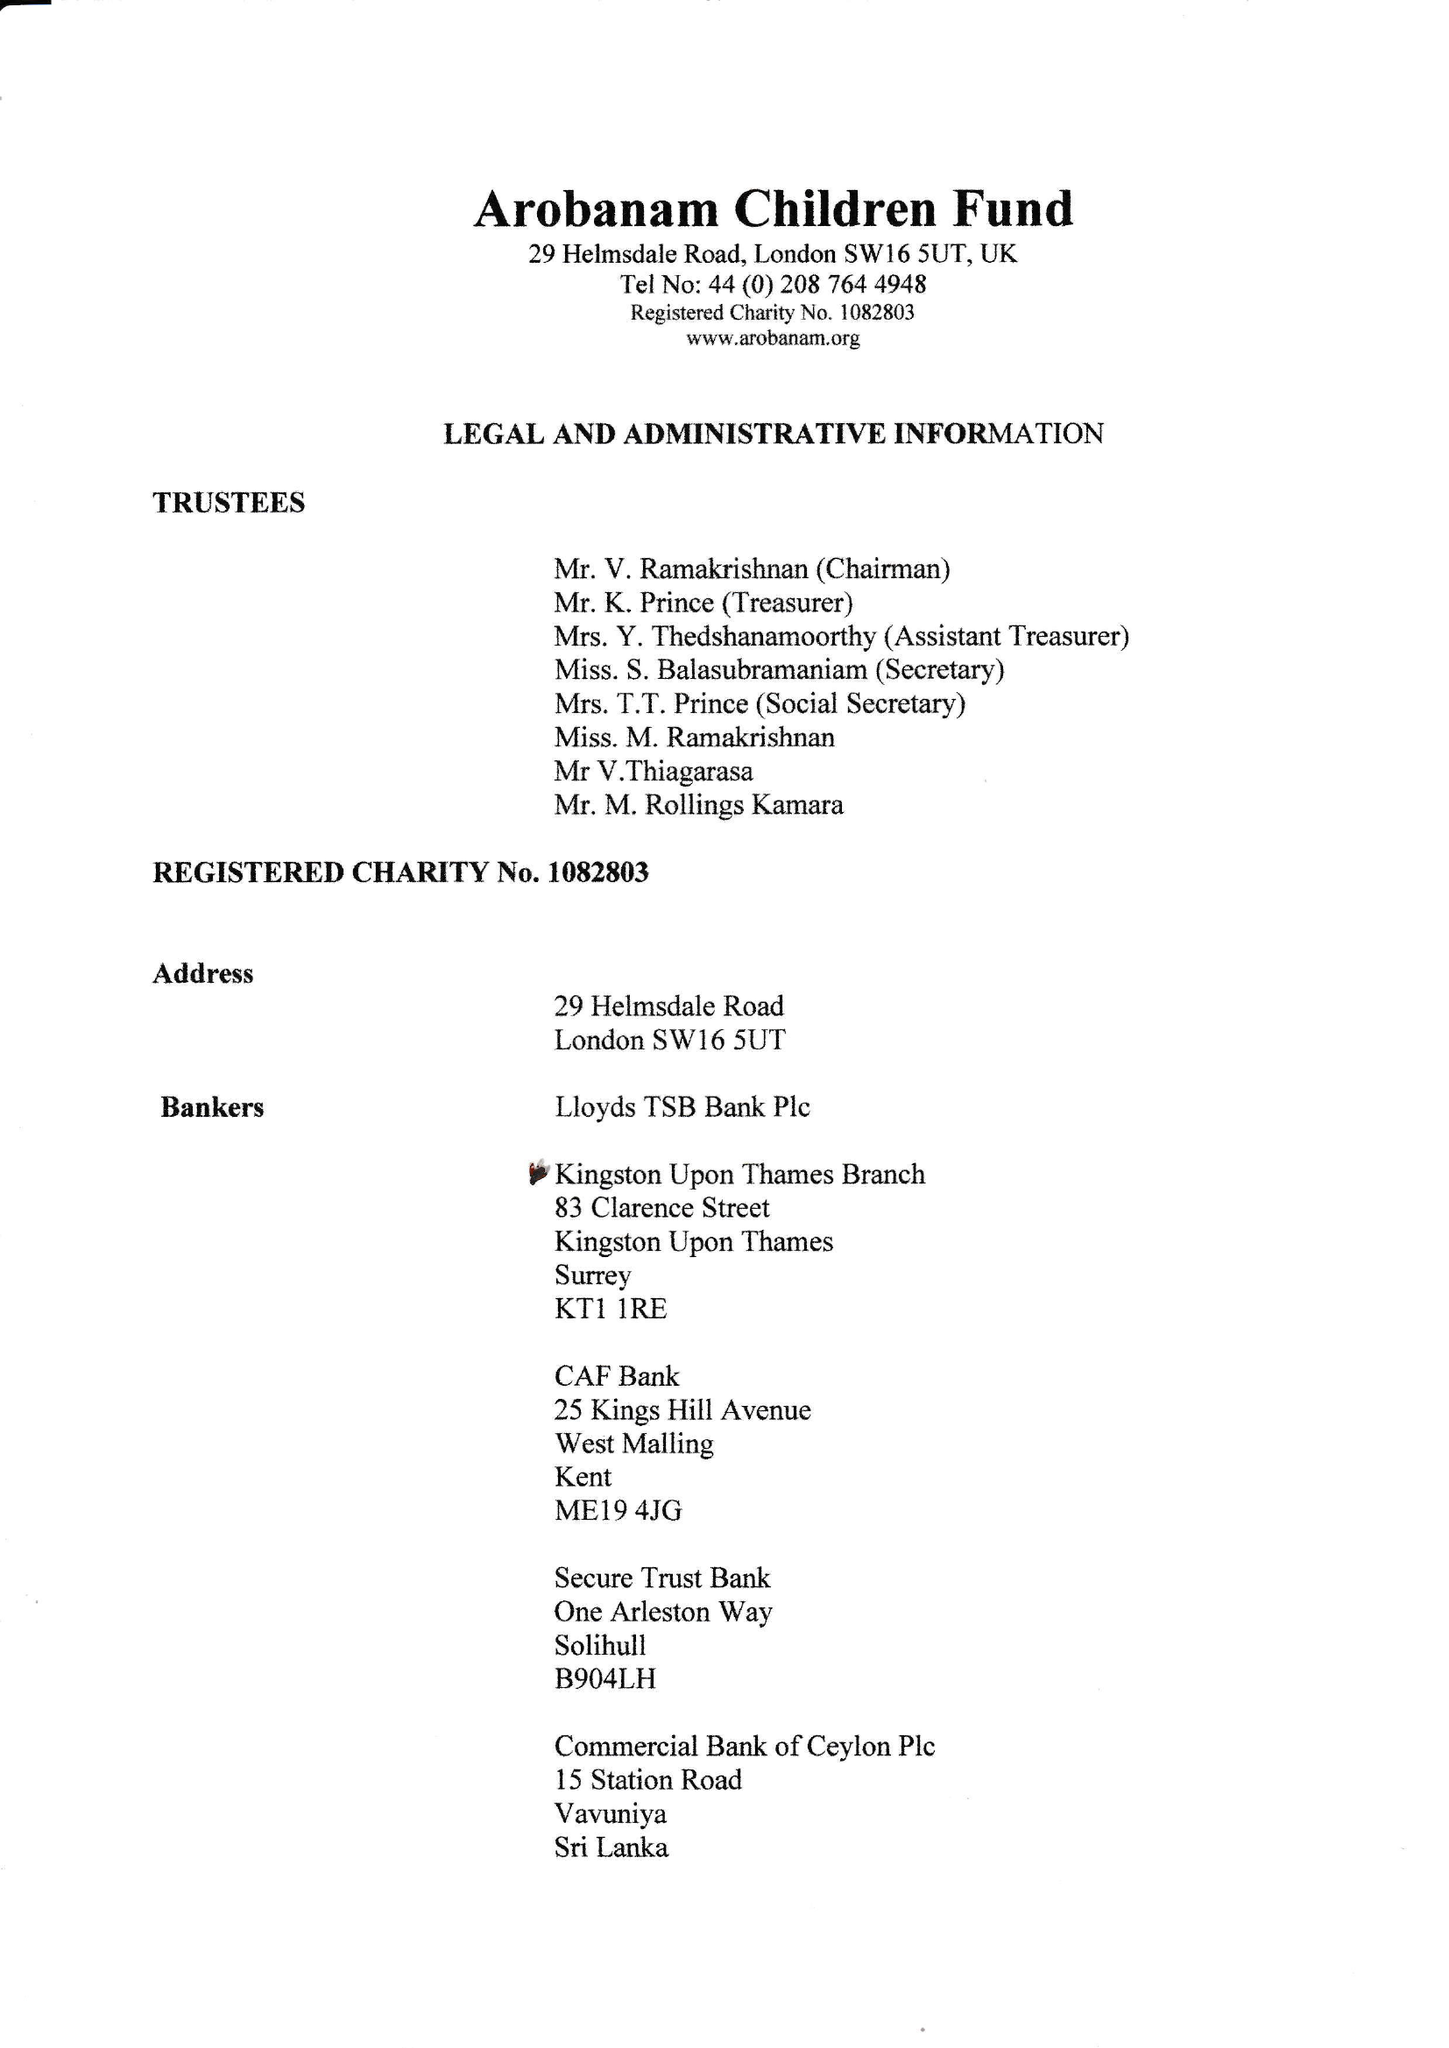What is the value for the report_date?
Answer the question using a single word or phrase. 2016-12-31 